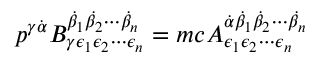<formula> <loc_0><loc_0><loc_500><loc_500>p ^ { \gamma { \dot { \alpha } } } B _ { \gamma \epsilon _ { 1 } \epsilon _ { 2 } \cdots \epsilon _ { n } } ^ { { \dot { \beta } } _ { 1 } { \dot { \beta } } _ { 2 } \cdots { \dot { \beta } } _ { n } } = m c A _ { \epsilon _ { 1 } \epsilon _ { 2 } \cdots \epsilon _ { n } } ^ { { \dot { \alpha } } { \dot { \beta } } _ { 1 } { \dot { \beta } } _ { 2 } \cdots { \dot { \beta } } _ { n } }</formula> 